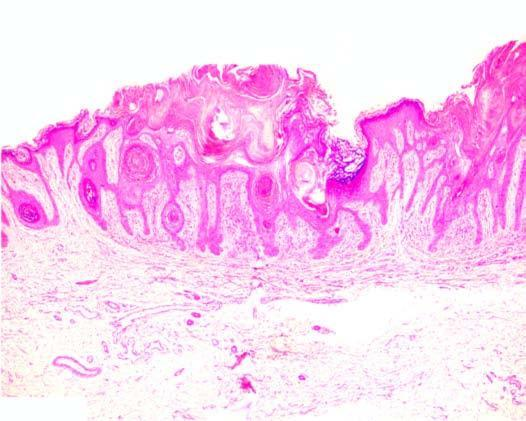do details include papillomatosis, hyperkeratosis and acanthosis?
Answer the question using a single word or phrase. No 